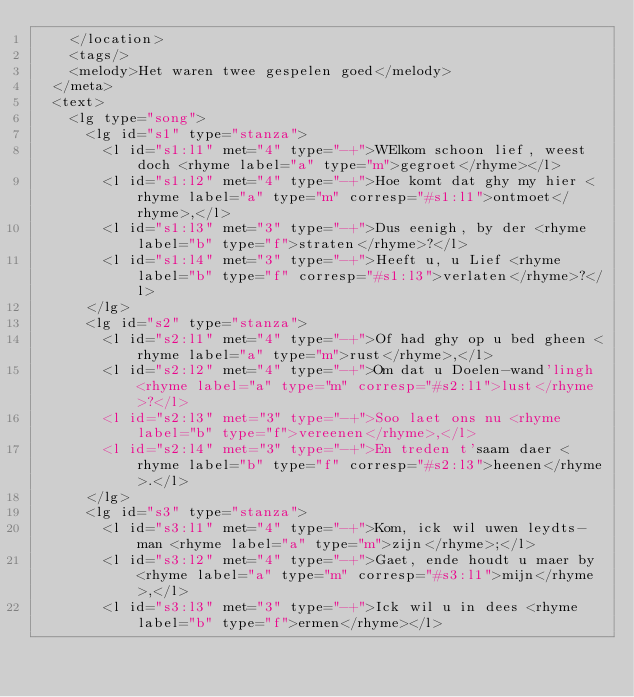<code> <loc_0><loc_0><loc_500><loc_500><_XML_>    </location>
    <tags/>
    <melody>Het waren twee gespelen goed</melody>
  </meta>
  <text>
    <lg type="song">
      <lg id="s1" type="stanza">
        <l id="s1:l1" met="4" type="-+">WElkom schoon lief, weest doch <rhyme label="a" type="m">gegroet</rhyme></l>
        <l id="s1:l2" met="4" type="-+">Hoe komt dat ghy my hier <rhyme label="a" type="m" corresp="#s1:l1">ontmoet</rhyme>,</l>
        <l id="s1:l3" met="3" type="-+">Dus eenigh, by der <rhyme label="b" type="f">straten</rhyme>?</l>
        <l id="s1:l4" met="3" type="-+">Heeft u, u Lief <rhyme label="b" type="f" corresp="#s1:l3">verlaten</rhyme>?</l>
      </lg>
      <lg id="s2" type="stanza">
        <l id="s2:l1" met="4" type="-+">Of had ghy op u bed gheen <rhyme label="a" type="m">rust</rhyme>,</l>
        <l id="s2:l2" met="4" type="-+">Om dat u Doelen-wand'lingh <rhyme label="a" type="m" corresp="#s2:l1">lust</rhyme>?</l>
        <l id="s2:l3" met="3" type="-+">Soo laet ons nu <rhyme label="b" type="f">vereenen</rhyme>,</l>
        <l id="s2:l4" met="3" type="-+">En treden t'saam daer <rhyme label="b" type="f" corresp="#s2:l3">heenen</rhyme>.</l>
      </lg>
      <lg id="s3" type="stanza">
        <l id="s3:l1" met="4" type="-+">Kom, ick wil uwen leydts-man <rhyme label="a" type="m">zijn</rhyme>;</l>
        <l id="s3:l2" met="4" type="-+">Gaet, ende houdt u maer by <rhyme label="a" type="m" corresp="#s3:l1">mijn</rhyme>,</l>
        <l id="s3:l3" met="3" type="-+">Ick wil u in dees <rhyme label="b" type="f">ermen</rhyme></l></code> 